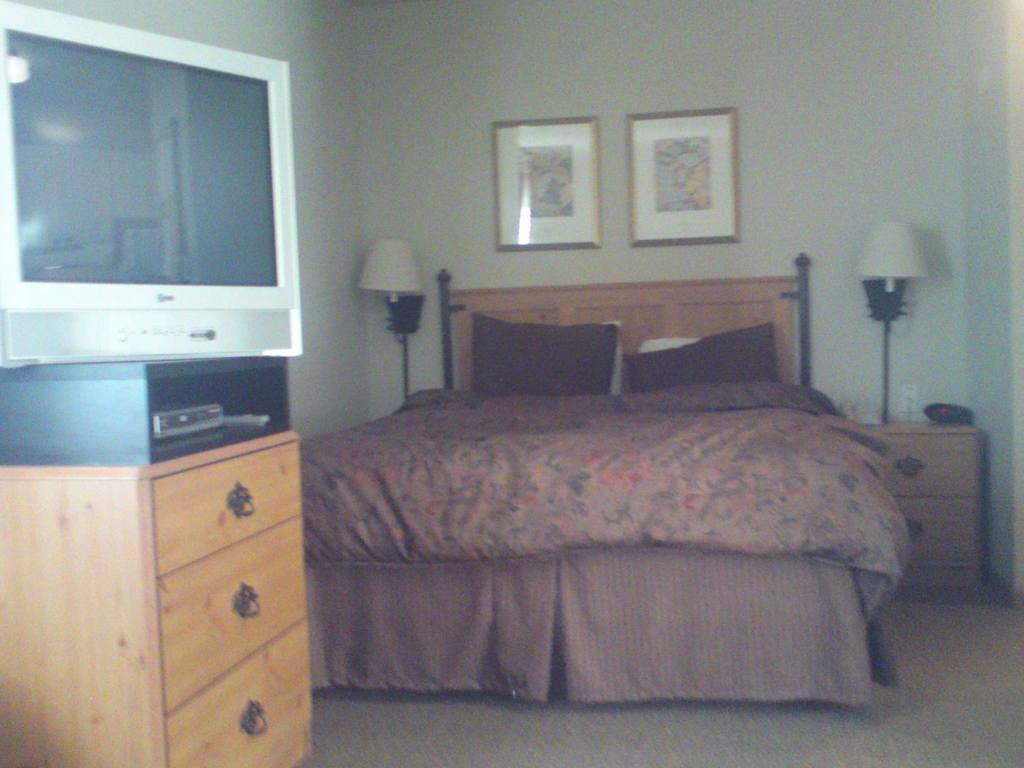Please provide a concise description of this image. This picture is taken in a room, In the middle there is a bed which is in yellow color, In the left side there is a desk which is in yellow color on that there is a black color object, There is a television which is in white color, In the right side there is a yellow color table on that there is a white color light. 